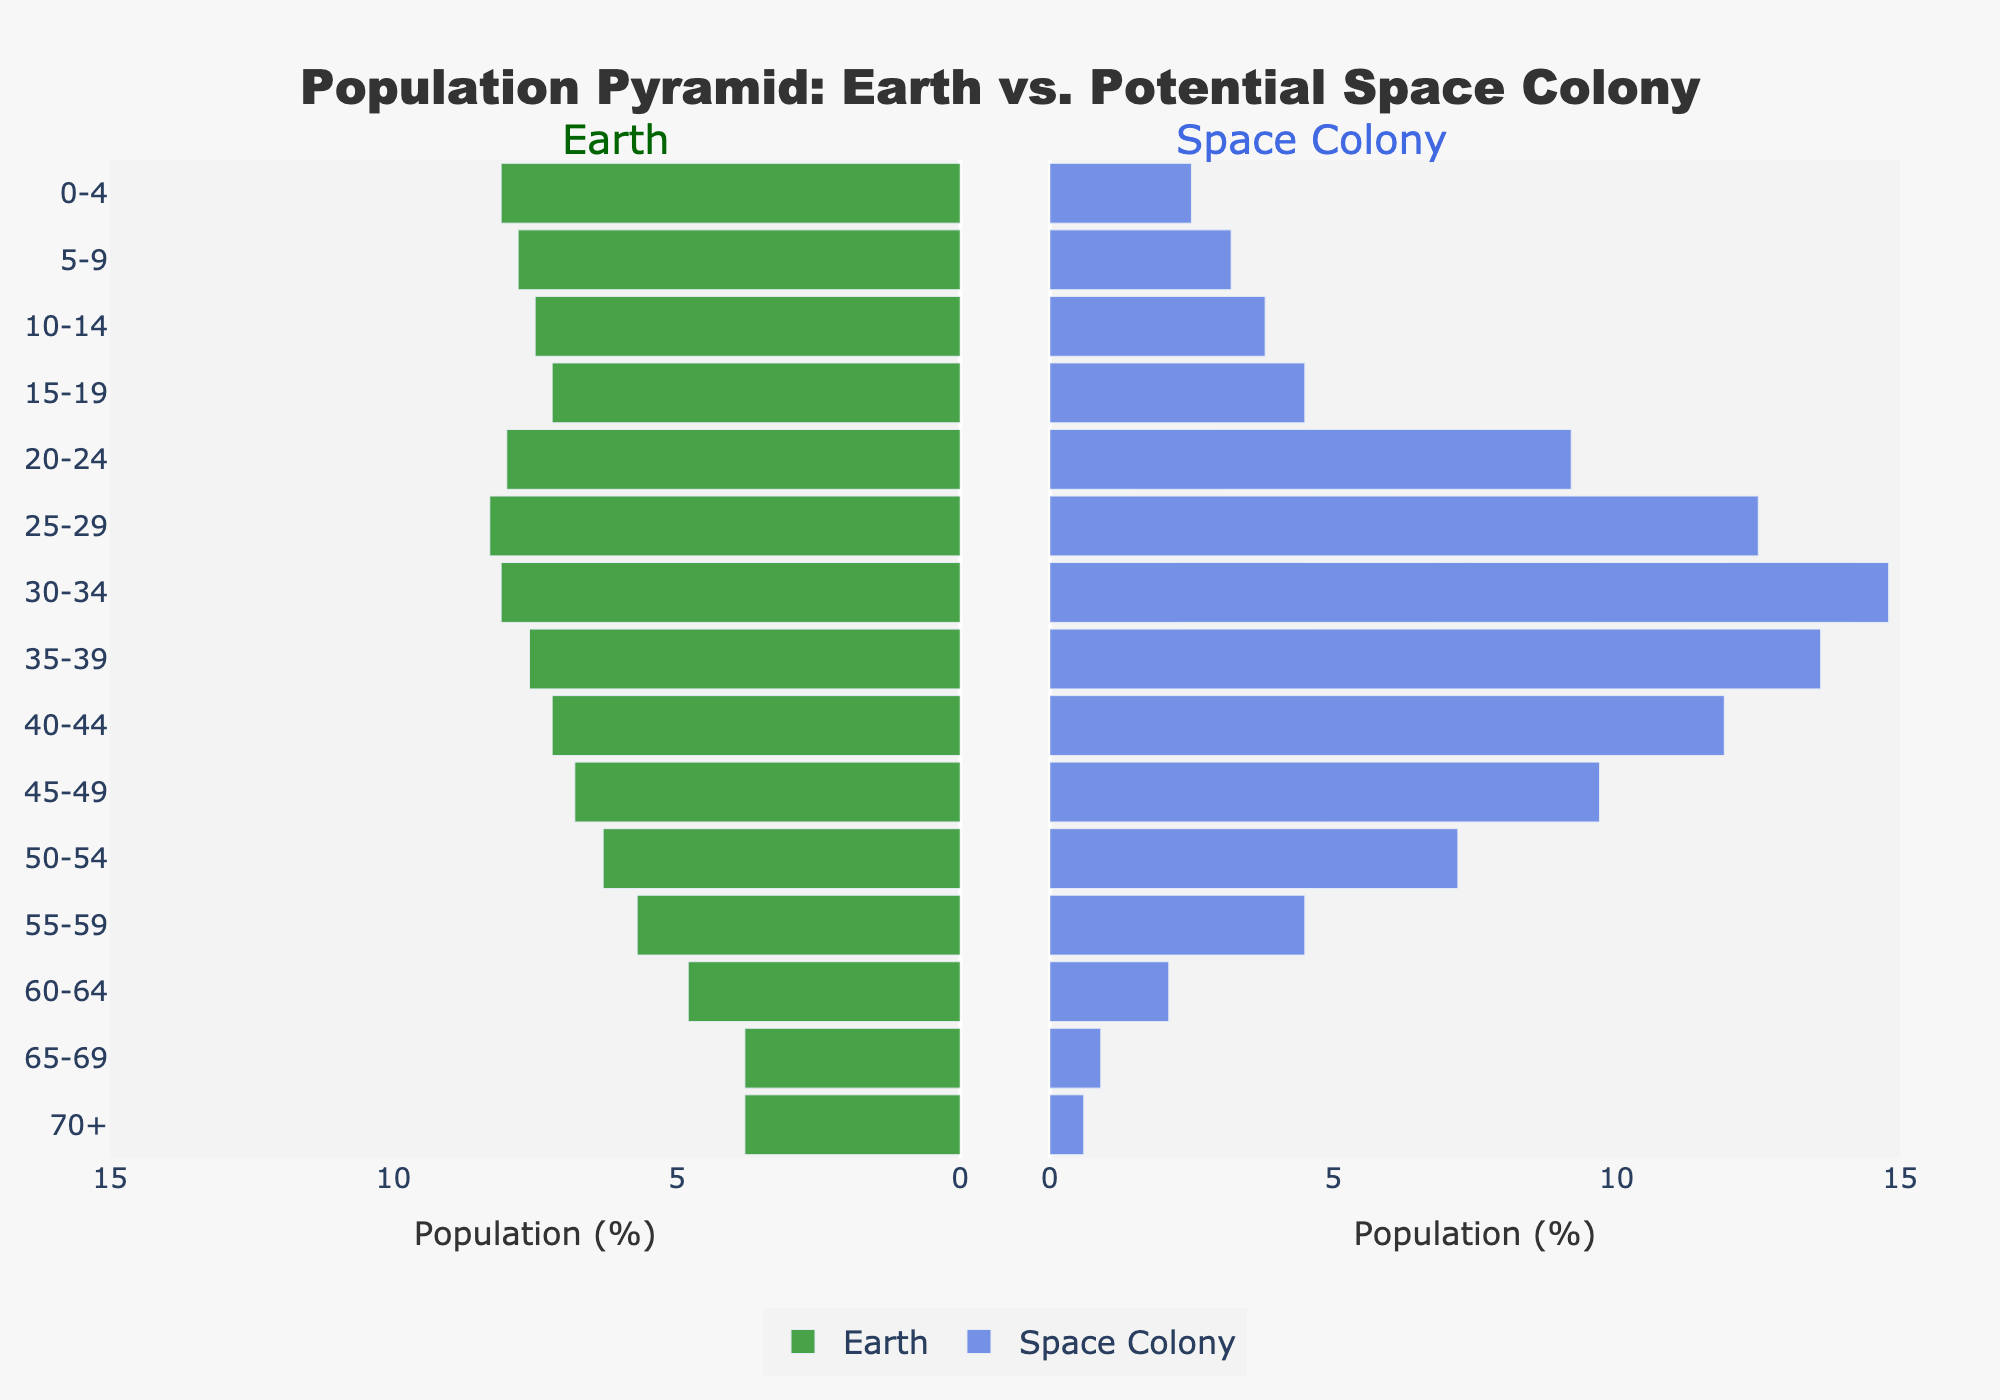What is the title of the figure? The title of the figure is placed at the top and reads, "Population Pyramid: Earth vs. Potential Space Colony".
Answer: "Population Pyramid: Earth vs. Potential Space Colony" How is the population percentage of age group 30-34 different between Earth and Space Colony? For the age group 30-34, the population percentage for Earth is 8.1% and for Space Colony is 14.8%. By subtracting the Earth percentage from the Space Colony percentage, we get 14.8% - 8.1% = 6.7%.
Answer: 6.7% Which demographic has a larger population percentage in the age group 25-29? The population percentage for the age group 25-29 is 8.3% on Earth and 12.5% in the Space Colony. Since 12.5% > 8.3%, the Space Colony has a larger population percentage for that age group.
Answer: Space Colony What is the average population percentage for age groups 60-64 and 70+ on Earth? For Earth, the population percentage for age groups 60-64 and 70+ are 4.8% and 3.8%, respectively. The average is calculated as (4.8% + 3.8%) / 2 = 4.3%.
Answer: 4.3% What color represents the Earth population bars in the figure? The Earth population bars are colored in green based on the visual markings in the figure.
Answer: Green Which age group has the highest proportion of the population in the Space Colony? The age group 30-34 has the highest proportion of the population in the Space Colony with 14.8%.
Answer: 30-34 At what age group does the population distribution start to decline rapidly for both Earth and the Space Colony? For both Earth and the Space Colony, the population distribution starts to decline rapidly at the age group 35-39 onward. This is evident by observing the downward trend in the bar lengths past this age group.
Answer: 35-39 